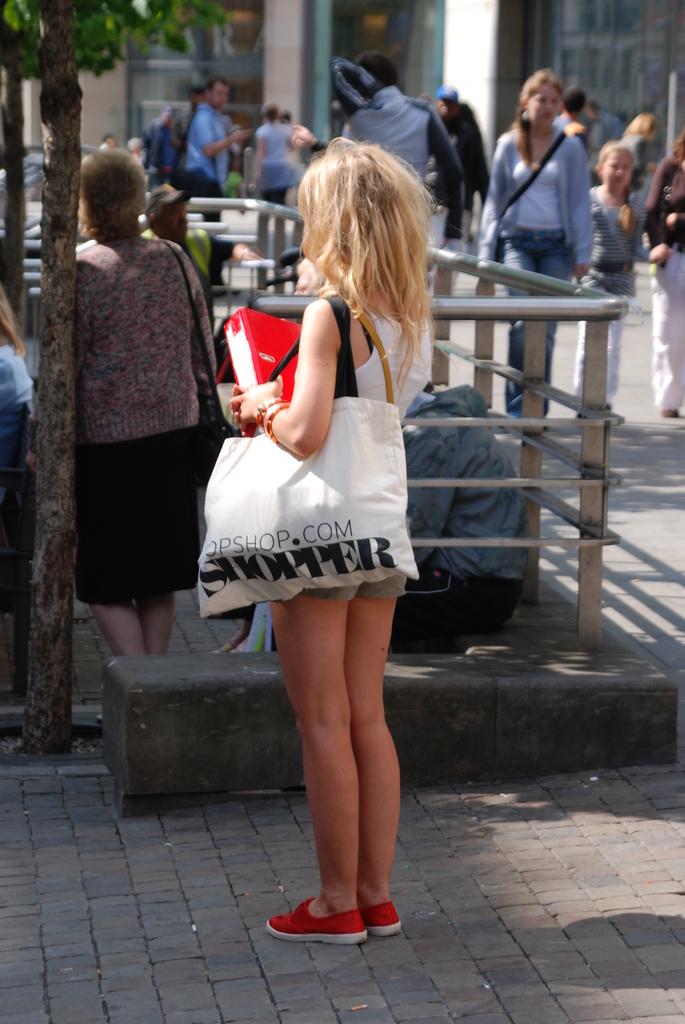What's the website?
Ensure brevity in your answer.  Opshop.com. 